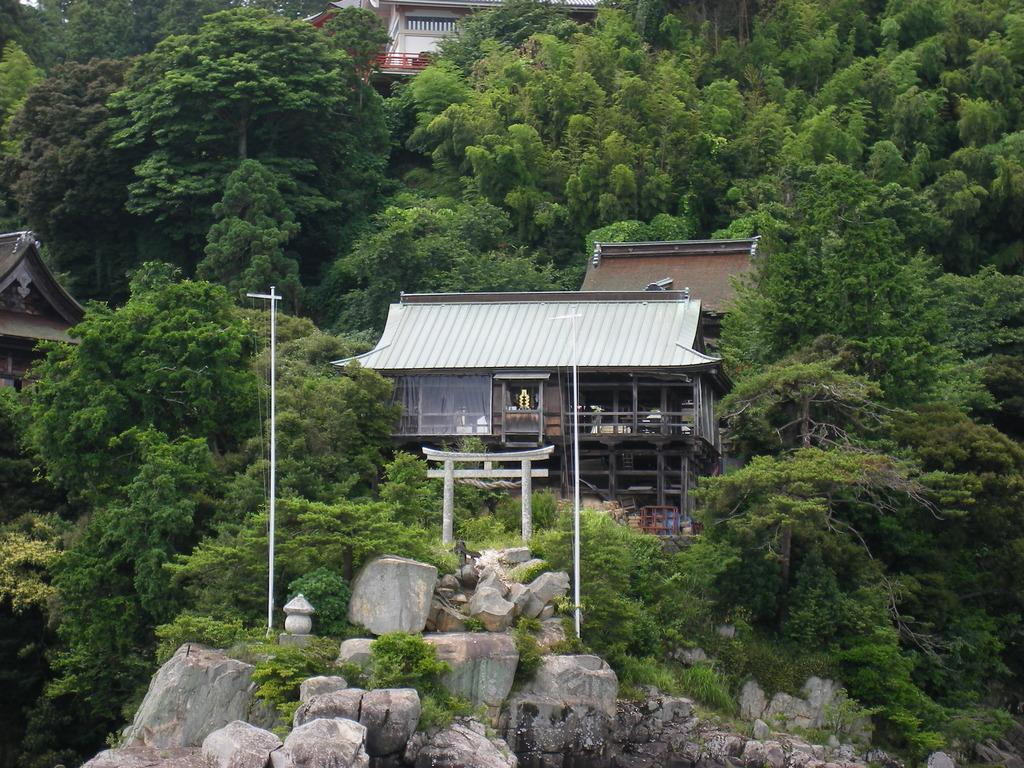What type of setting is depicted in the image? The image is an outside view. What can be seen at the bottom of the image? There are rocks at the bottom of the image. How many poles are visible in the image? There are two poles in the image. What is visible in the background of the image? There are buildings and many trees in the background of the image. What type of activity is the chain performing in the image? There is no chain present in the image. Who is responsible for the care of the trees in the background of the image? The image does not provide information about who is responsible for the care of the trees. 